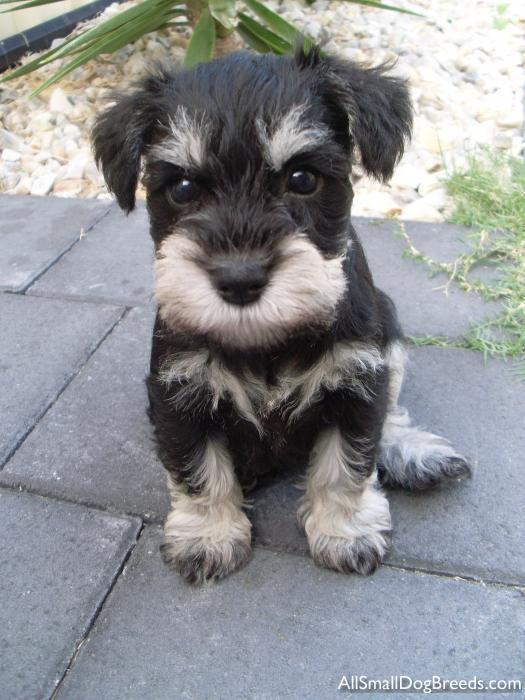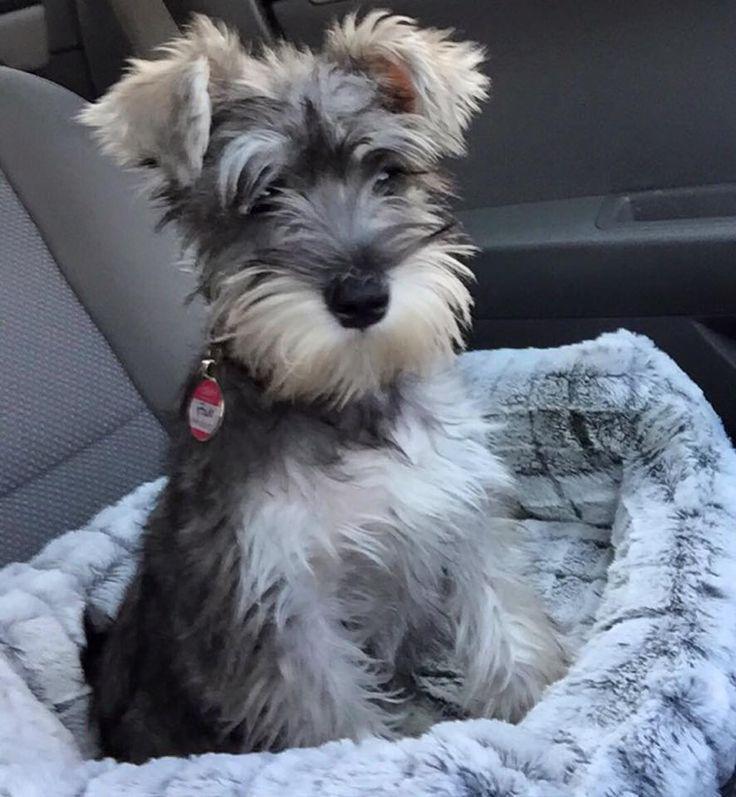The first image is the image on the left, the second image is the image on the right. For the images displayed, is the sentence "An image shows exactly one schnauzer, which stands on all fours facing leftward." factually correct? Answer yes or no. No. The first image is the image on the left, the second image is the image on the right. Evaluate the accuracy of this statement regarding the images: "One dog's body is facing to the left.". Is it true? Answer yes or no. No. 